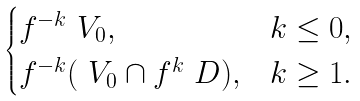<formula> <loc_0><loc_0><loc_500><loc_500>\begin{cases} f ^ { - k } \ V _ { 0 } , & k \leq 0 , \\ f ^ { - k } ( \ V _ { 0 } \cap f ^ { k } \ D ) , & k \geq 1 . \end{cases}</formula> 